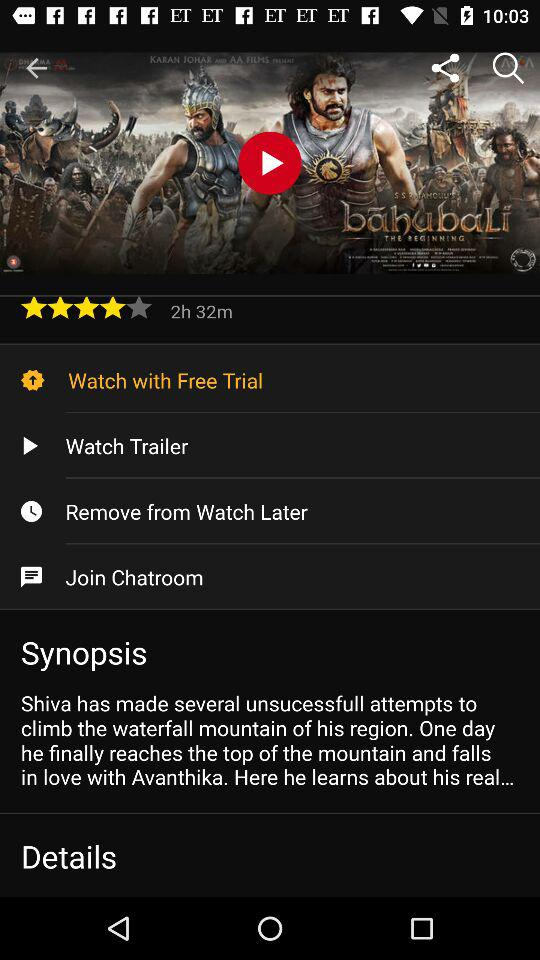What is the given rating? The rating is 4 stars. 